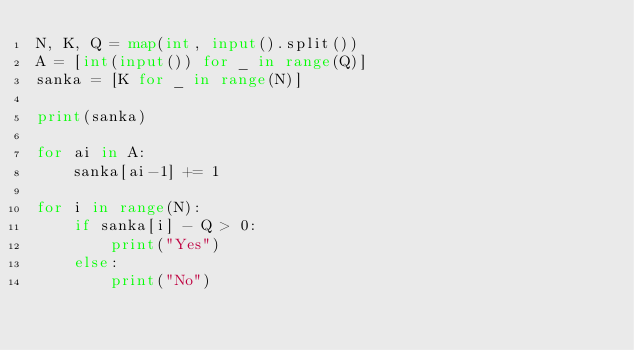<code> <loc_0><loc_0><loc_500><loc_500><_Python_>N, K, Q = map(int, input().split())
A = [int(input()) for _ in range(Q)]
sanka = [K for _ in range(N)]

print(sanka)

for ai in A:
    sanka[ai-1] += 1

for i in range(N):
    if sanka[i] - Q > 0:
        print("Yes")
    else:
        print("No")
</code> 